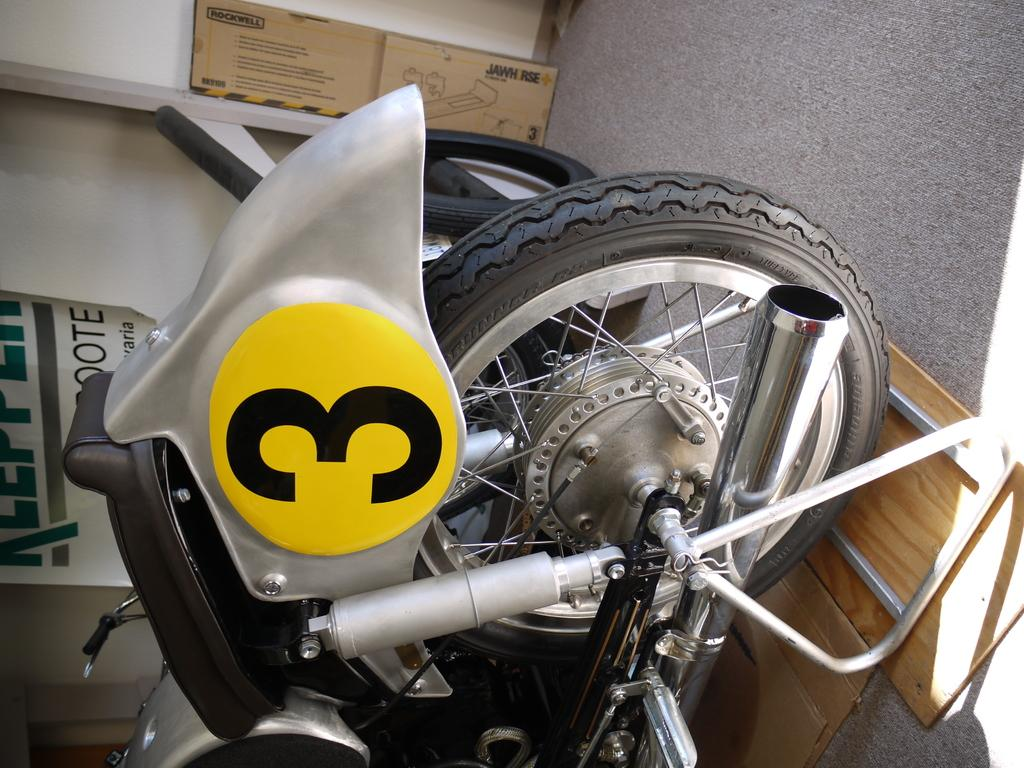<image>
Offer a succinct explanation of the picture presented. A box that says "ROCKWELL" is behind a motorcycle with a "3" on it. 